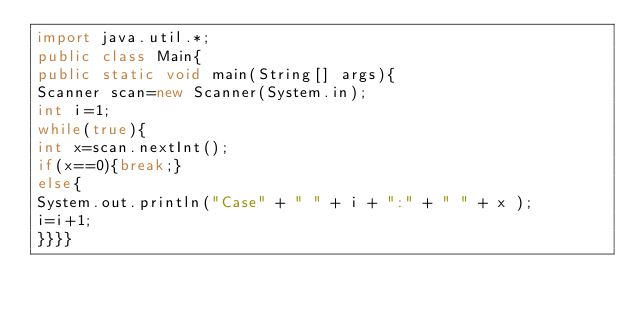<code> <loc_0><loc_0><loc_500><loc_500><_Java_>import java.util.*;
public class Main{
public static void main(String[] args){
Scanner scan=new Scanner(System.in);
int i=1;
while(true){
int x=scan.nextInt();
if(x==0){break;}
else{
System.out.println("Case" + " " + i + ":" + " " + x );
i=i+1;
}}}}</code> 